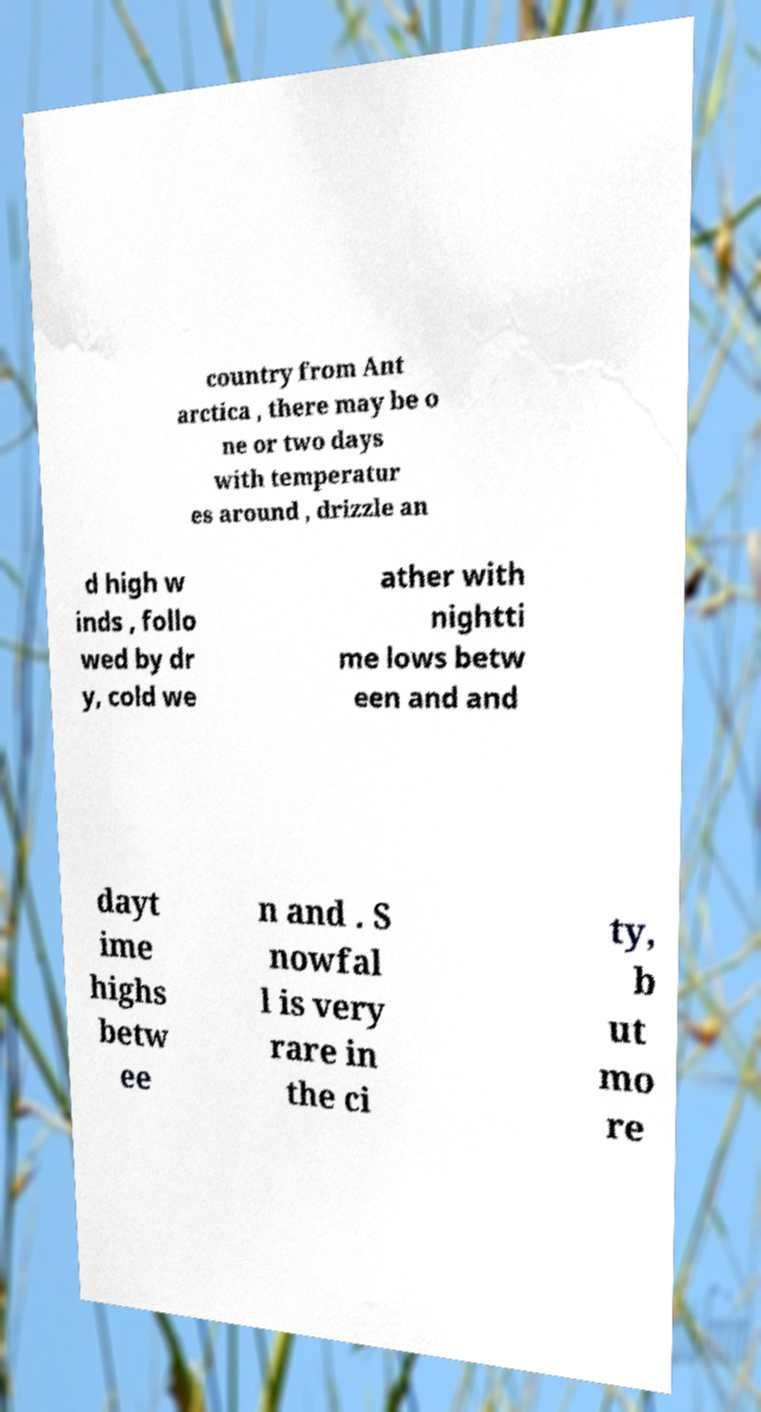I need the written content from this picture converted into text. Can you do that? country from Ant arctica , there may be o ne or two days with temperatur es around , drizzle an d high w inds , follo wed by dr y, cold we ather with nightti me lows betw een and and dayt ime highs betw ee n and . S nowfal l is very rare in the ci ty, b ut mo re 